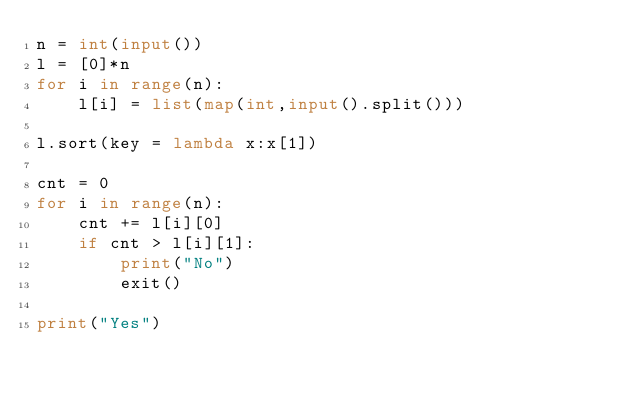Convert code to text. <code><loc_0><loc_0><loc_500><loc_500><_Python_>n = int(input())
l = [0]*n
for i in range(n):
    l[i] = list(map(int,input().split()))

l.sort(key = lambda x:x[1])

cnt = 0
for i in range(n):
    cnt += l[i][0]
    if cnt > l[i][1]:
        print("No")
        exit()

print("Yes")</code> 